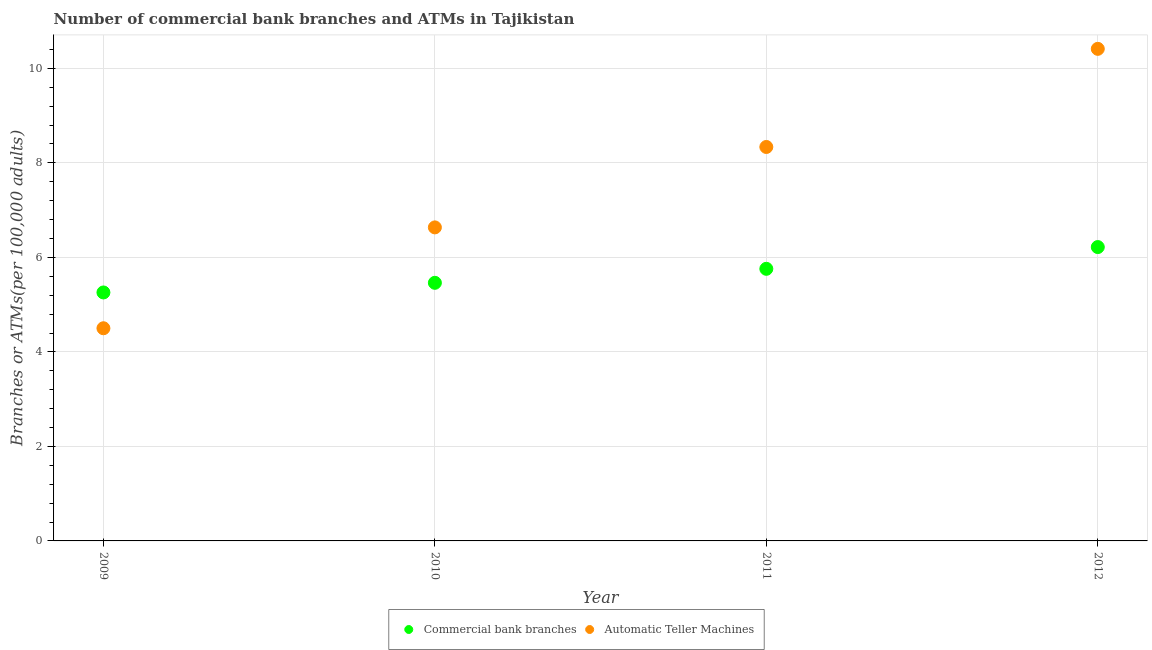What is the number of commercal bank branches in 2009?
Your answer should be compact. 5.26. Across all years, what is the maximum number of commercal bank branches?
Give a very brief answer. 6.22. Across all years, what is the minimum number of commercal bank branches?
Your response must be concise. 5.26. What is the total number of atms in the graph?
Your answer should be compact. 29.89. What is the difference between the number of commercal bank branches in 2009 and that in 2012?
Offer a terse response. -0.96. What is the difference between the number of atms in 2011 and the number of commercal bank branches in 2012?
Provide a succinct answer. 2.12. What is the average number of commercal bank branches per year?
Your response must be concise. 5.67. In the year 2012, what is the difference between the number of commercal bank branches and number of atms?
Give a very brief answer. -4.19. What is the ratio of the number of commercal bank branches in 2009 to that in 2011?
Your answer should be compact. 0.91. Is the number of commercal bank branches in 2010 less than that in 2011?
Your answer should be very brief. Yes. What is the difference between the highest and the second highest number of atms?
Give a very brief answer. 2.08. What is the difference between the highest and the lowest number of atms?
Offer a terse response. 5.91. Is the sum of the number of atms in 2010 and 2012 greater than the maximum number of commercal bank branches across all years?
Provide a succinct answer. Yes. Does the number of atms monotonically increase over the years?
Ensure brevity in your answer.  Yes. Is the number of commercal bank branches strictly less than the number of atms over the years?
Ensure brevity in your answer.  No. How many dotlines are there?
Your answer should be compact. 2. How many years are there in the graph?
Your answer should be compact. 4. What is the difference between two consecutive major ticks on the Y-axis?
Your answer should be compact. 2. Does the graph contain grids?
Your answer should be compact. Yes. How many legend labels are there?
Your answer should be compact. 2. What is the title of the graph?
Your response must be concise. Number of commercial bank branches and ATMs in Tajikistan. What is the label or title of the Y-axis?
Provide a succinct answer. Branches or ATMs(per 100,0 adults). What is the Branches or ATMs(per 100,000 adults) in Commercial bank branches in 2009?
Make the answer very short. 5.26. What is the Branches or ATMs(per 100,000 adults) of Automatic Teller Machines in 2009?
Keep it short and to the point. 4.5. What is the Branches or ATMs(per 100,000 adults) of Commercial bank branches in 2010?
Ensure brevity in your answer.  5.46. What is the Branches or ATMs(per 100,000 adults) of Automatic Teller Machines in 2010?
Your answer should be compact. 6.64. What is the Branches or ATMs(per 100,000 adults) of Commercial bank branches in 2011?
Offer a terse response. 5.76. What is the Branches or ATMs(per 100,000 adults) in Automatic Teller Machines in 2011?
Your answer should be compact. 8.34. What is the Branches or ATMs(per 100,000 adults) in Commercial bank branches in 2012?
Make the answer very short. 6.22. What is the Branches or ATMs(per 100,000 adults) in Automatic Teller Machines in 2012?
Ensure brevity in your answer.  10.41. Across all years, what is the maximum Branches or ATMs(per 100,000 adults) of Commercial bank branches?
Keep it short and to the point. 6.22. Across all years, what is the maximum Branches or ATMs(per 100,000 adults) in Automatic Teller Machines?
Offer a terse response. 10.41. Across all years, what is the minimum Branches or ATMs(per 100,000 adults) of Commercial bank branches?
Offer a terse response. 5.26. Across all years, what is the minimum Branches or ATMs(per 100,000 adults) of Automatic Teller Machines?
Your answer should be very brief. 4.5. What is the total Branches or ATMs(per 100,000 adults) in Commercial bank branches in the graph?
Offer a very short reply. 22.7. What is the total Branches or ATMs(per 100,000 adults) of Automatic Teller Machines in the graph?
Offer a very short reply. 29.89. What is the difference between the Branches or ATMs(per 100,000 adults) of Commercial bank branches in 2009 and that in 2010?
Your answer should be compact. -0.2. What is the difference between the Branches or ATMs(per 100,000 adults) of Automatic Teller Machines in 2009 and that in 2010?
Provide a short and direct response. -2.13. What is the difference between the Branches or ATMs(per 100,000 adults) of Commercial bank branches in 2009 and that in 2011?
Your answer should be compact. -0.5. What is the difference between the Branches or ATMs(per 100,000 adults) in Automatic Teller Machines in 2009 and that in 2011?
Provide a short and direct response. -3.84. What is the difference between the Branches or ATMs(per 100,000 adults) of Commercial bank branches in 2009 and that in 2012?
Your response must be concise. -0.96. What is the difference between the Branches or ATMs(per 100,000 adults) in Automatic Teller Machines in 2009 and that in 2012?
Offer a very short reply. -5.91. What is the difference between the Branches or ATMs(per 100,000 adults) in Commercial bank branches in 2010 and that in 2011?
Offer a very short reply. -0.3. What is the difference between the Branches or ATMs(per 100,000 adults) of Automatic Teller Machines in 2010 and that in 2011?
Keep it short and to the point. -1.7. What is the difference between the Branches or ATMs(per 100,000 adults) of Commercial bank branches in 2010 and that in 2012?
Your response must be concise. -0.76. What is the difference between the Branches or ATMs(per 100,000 adults) in Automatic Teller Machines in 2010 and that in 2012?
Keep it short and to the point. -3.78. What is the difference between the Branches or ATMs(per 100,000 adults) in Commercial bank branches in 2011 and that in 2012?
Keep it short and to the point. -0.46. What is the difference between the Branches or ATMs(per 100,000 adults) of Automatic Teller Machines in 2011 and that in 2012?
Ensure brevity in your answer.  -2.08. What is the difference between the Branches or ATMs(per 100,000 adults) in Commercial bank branches in 2009 and the Branches or ATMs(per 100,000 adults) in Automatic Teller Machines in 2010?
Provide a succinct answer. -1.38. What is the difference between the Branches or ATMs(per 100,000 adults) of Commercial bank branches in 2009 and the Branches or ATMs(per 100,000 adults) of Automatic Teller Machines in 2011?
Provide a succinct answer. -3.08. What is the difference between the Branches or ATMs(per 100,000 adults) in Commercial bank branches in 2009 and the Branches or ATMs(per 100,000 adults) in Automatic Teller Machines in 2012?
Your answer should be very brief. -5.16. What is the difference between the Branches or ATMs(per 100,000 adults) of Commercial bank branches in 2010 and the Branches or ATMs(per 100,000 adults) of Automatic Teller Machines in 2011?
Your response must be concise. -2.87. What is the difference between the Branches or ATMs(per 100,000 adults) of Commercial bank branches in 2010 and the Branches or ATMs(per 100,000 adults) of Automatic Teller Machines in 2012?
Offer a very short reply. -4.95. What is the difference between the Branches or ATMs(per 100,000 adults) of Commercial bank branches in 2011 and the Branches or ATMs(per 100,000 adults) of Automatic Teller Machines in 2012?
Offer a terse response. -4.66. What is the average Branches or ATMs(per 100,000 adults) in Commercial bank branches per year?
Your answer should be compact. 5.67. What is the average Branches or ATMs(per 100,000 adults) of Automatic Teller Machines per year?
Offer a terse response. 7.47. In the year 2009, what is the difference between the Branches or ATMs(per 100,000 adults) of Commercial bank branches and Branches or ATMs(per 100,000 adults) of Automatic Teller Machines?
Offer a very short reply. 0.76. In the year 2010, what is the difference between the Branches or ATMs(per 100,000 adults) of Commercial bank branches and Branches or ATMs(per 100,000 adults) of Automatic Teller Machines?
Offer a very short reply. -1.17. In the year 2011, what is the difference between the Branches or ATMs(per 100,000 adults) in Commercial bank branches and Branches or ATMs(per 100,000 adults) in Automatic Teller Machines?
Provide a short and direct response. -2.58. In the year 2012, what is the difference between the Branches or ATMs(per 100,000 adults) of Commercial bank branches and Branches or ATMs(per 100,000 adults) of Automatic Teller Machines?
Keep it short and to the point. -4.19. What is the ratio of the Branches or ATMs(per 100,000 adults) of Commercial bank branches in 2009 to that in 2010?
Your answer should be very brief. 0.96. What is the ratio of the Branches or ATMs(per 100,000 adults) of Automatic Teller Machines in 2009 to that in 2010?
Your response must be concise. 0.68. What is the ratio of the Branches or ATMs(per 100,000 adults) of Commercial bank branches in 2009 to that in 2011?
Keep it short and to the point. 0.91. What is the ratio of the Branches or ATMs(per 100,000 adults) of Automatic Teller Machines in 2009 to that in 2011?
Provide a short and direct response. 0.54. What is the ratio of the Branches or ATMs(per 100,000 adults) of Commercial bank branches in 2009 to that in 2012?
Your response must be concise. 0.85. What is the ratio of the Branches or ATMs(per 100,000 adults) in Automatic Teller Machines in 2009 to that in 2012?
Make the answer very short. 0.43. What is the ratio of the Branches or ATMs(per 100,000 adults) of Commercial bank branches in 2010 to that in 2011?
Keep it short and to the point. 0.95. What is the ratio of the Branches or ATMs(per 100,000 adults) of Automatic Teller Machines in 2010 to that in 2011?
Your answer should be very brief. 0.8. What is the ratio of the Branches or ATMs(per 100,000 adults) in Commercial bank branches in 2010 to that in 2012?
Give a very brief answer. 0.88. What is the ratio of the Branches or ATMs(per 100,000 adults) in Automatic Teller Machines in 2010 to that in 2012?
Your response must be concise. 0.64. What is the ratio of the Branches or ATMs(per 100,000 adults) of Commercial bank branches in 2011 to that in 2012?
Offer a very short reply. 0.93. What is the ratio of the Branches or ATMs(per 100,000 adults) in Automatic Teller Machines in 2011 to that in 2012?
Make the answer very short. 0.8. What is the difference between the highest and the second highest Branches or ATMs(per 100,000 adults) in Commercial bank branches?
Offer a very short reply. 0.46. What is the difference between the highest and the second highest Branches or ATMs(per 100,000 adults) of Automatic Teller Machines?
Keep it short and to the point. 2.08. What is the difference between the highest and the lowest Branches or ATMs(per 100,000 adults) in Commercial bank branches?
Provide a short and direct response. 0.96. What is the difference between the highest and the lowest Branches or ATMs(per 100,000 adults) of Automatic Teller Machines?
Provide a succinct answer. 5.91. 